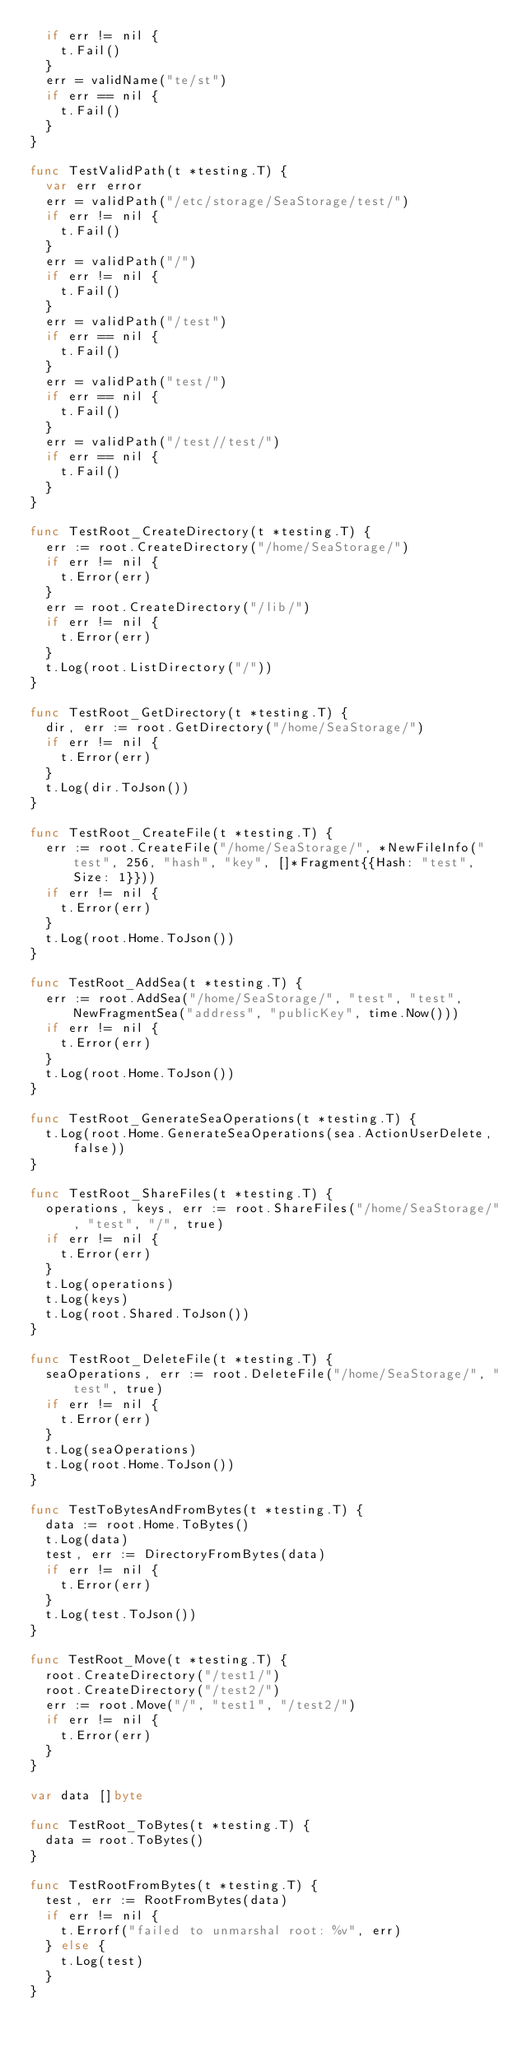Convert code to text. <code><loc_0><loc_0><loc_500><loc_500><_Go_>	if err != nil {
		t.Fail()
	}
	err = validName("te/st")
	if err == nil {
		t.Fail()
	}
}

func TestValidPath(t *testing.T) {
	var err error
	err = validPath("/etc/storage/SeaStorage/test/")
	if err != nil {
		t.Fail()
	}
	err = validPath("/")
	if err != nil {
		t.Fail()
	}
	err = validPath("/test")
	if err == nil {
		t.Fail()
	}
	err = validPath("test/")
	if err == nil {
		t.Fail()
	}
	err = validPath("/test//test/")
	if err == nil {
		t.Fail()
	}
}

func TestRoot_CreateDirectory(t *testing.T) {
	err := root.CreateDirectory("/home/SeaStorage/")
	if err != nil {
		t.Error(err)
	}
	err = root.CreateDirectory("/lib/")
	if err != nil {
		t.Error(err)
	}
	t.Log(root.ListDirectory("/"))
}

func TestRoot_GetDirectory(t *testing.T) {
	dir, err := root.GetDirectory("/home/SeaStorage/")
	if err != nil {
		t.Error(err)
	}
	t.Log(dir.ToJson())
}

func TestRoot_CreateFile(t *testing.T) {
	err := root.CreateFile("/home/SeaStorage/", *NewFileInfo("test", 256, "hash", "key", []*Fragment{{Hash: "test", Size: 1}}))
	if err != nil {
		t.Error(err)
	}
	t.Log(root.Home.ToJson())
}

func TestRoot_AddSea(t *testing.T) {
	err := root.AddSea("/home/SeaStorage/", "test", "test", NewFragmentSea("address", "publicKey", time.Now()))
	if err != nil {
		t.Error(err)
	}
	t.Log(root.Home.ToJson())
}

func TestRoot_GenerateSeaOperations(t *testing.T) {
	t.Log(root.Home.GenerateSeaOperations(sea.ActionUserDelete, false))
}

func TestRoot_ShareFiles(t *testing.T) {
	operations, keys, err := root.ShareFiles("/home/SeaStorage/", "test", "/", true)
	if err != nil {
		t.Error(err)
	}
	t.Log(operations)
	t.Log(keys)
	t.Log(root.Shared.ToJson())
}

func TestRoot_DeleteFile(t *testing.T) {
	seaOperations, err := root.DeleteFile("/home/SeaStorage/", "test", true)
	if err != nil {
		t.Error(err)
	}
	t.Log(seaOperations)
	t.Log(root.Home.ToJson())
}

func TestToBytesAndFromBytes(t *testing.T) {
	data := root.Home.ToBytes()
	t.Log(data)
	test, err := DirectoryFromBytes(data)
	if err != nil {
		t.Error(err)
	}
	t.Log(test.ToJson())
}

func TestRoot_Move(t *testing.T) {
	root.CreateDirectory("/test1/")
	root.CreateDirectory("/test2/")
	err := root.Move("/", "test1", "/test2/")
	if err != nil {
		t.Error(err)
	}
}

var data []byte

func TestRoot_ToBytes(t *testing.T) {
	data = root.ToBytes()
}

func TestRootFromBytes(t *testing.T) {
	test, err := RootFromBytes(data)
	if err != nil {
		t.Errorf("failed to unmarshal root: %v", err)
	} else {
		t.Log(test)
	}
}
</code> 